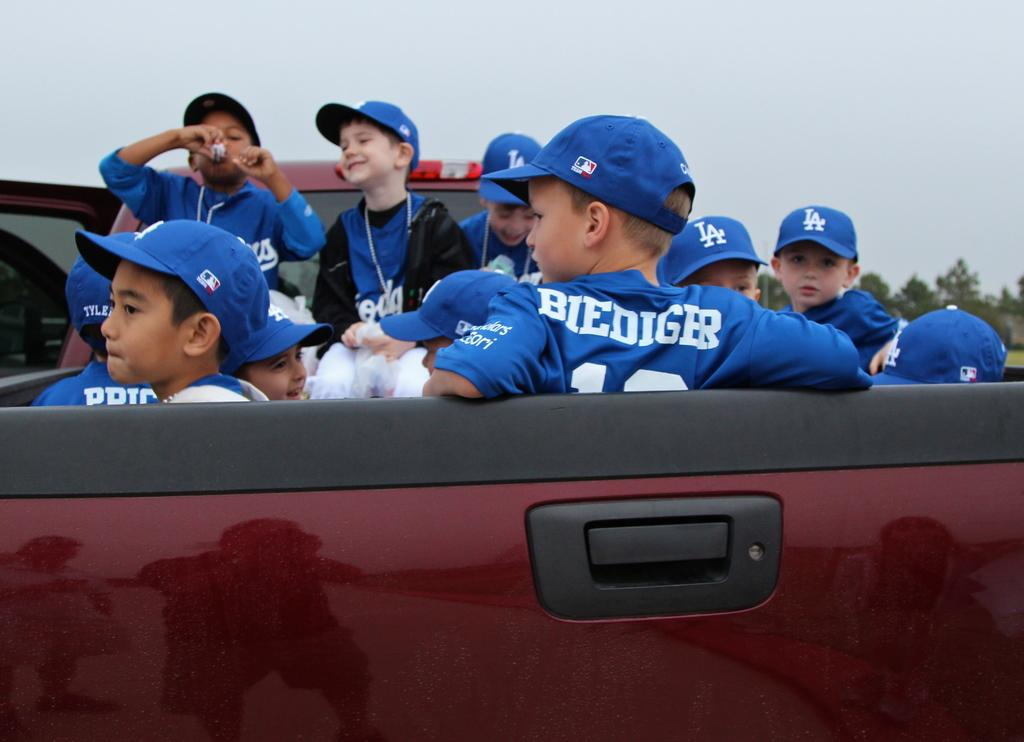<image>
Share a concise interpretation of the image provided. kids in the bed of a truck with one of them wearing a jersey that says 'biediger' 